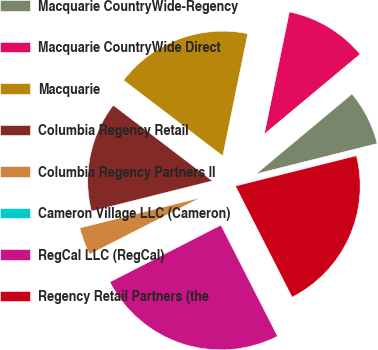<chart> <loc_0><loc_0><loc_500><loc_500><pie_chart><fcel>Macquarie CountryWide-Regency<fcel>Macquarie CountryWide Direct<fcel>Macquarie<fcel>Columbia Regency Retail<fcel>Columbia Regency Partners II<fcel>Cameron Village LLC (Cameron)<fcel>RegCal LLC (RegCal)<fcel>Regency Retail Partners (the<nl><fcel>7.16%<fcel>10.72%<fcel>17.84%<fcel>14.28%<fcel>3.6%<fcel>0.03%<fcel>24.97%<fcel>21.4%<nl></chart> 